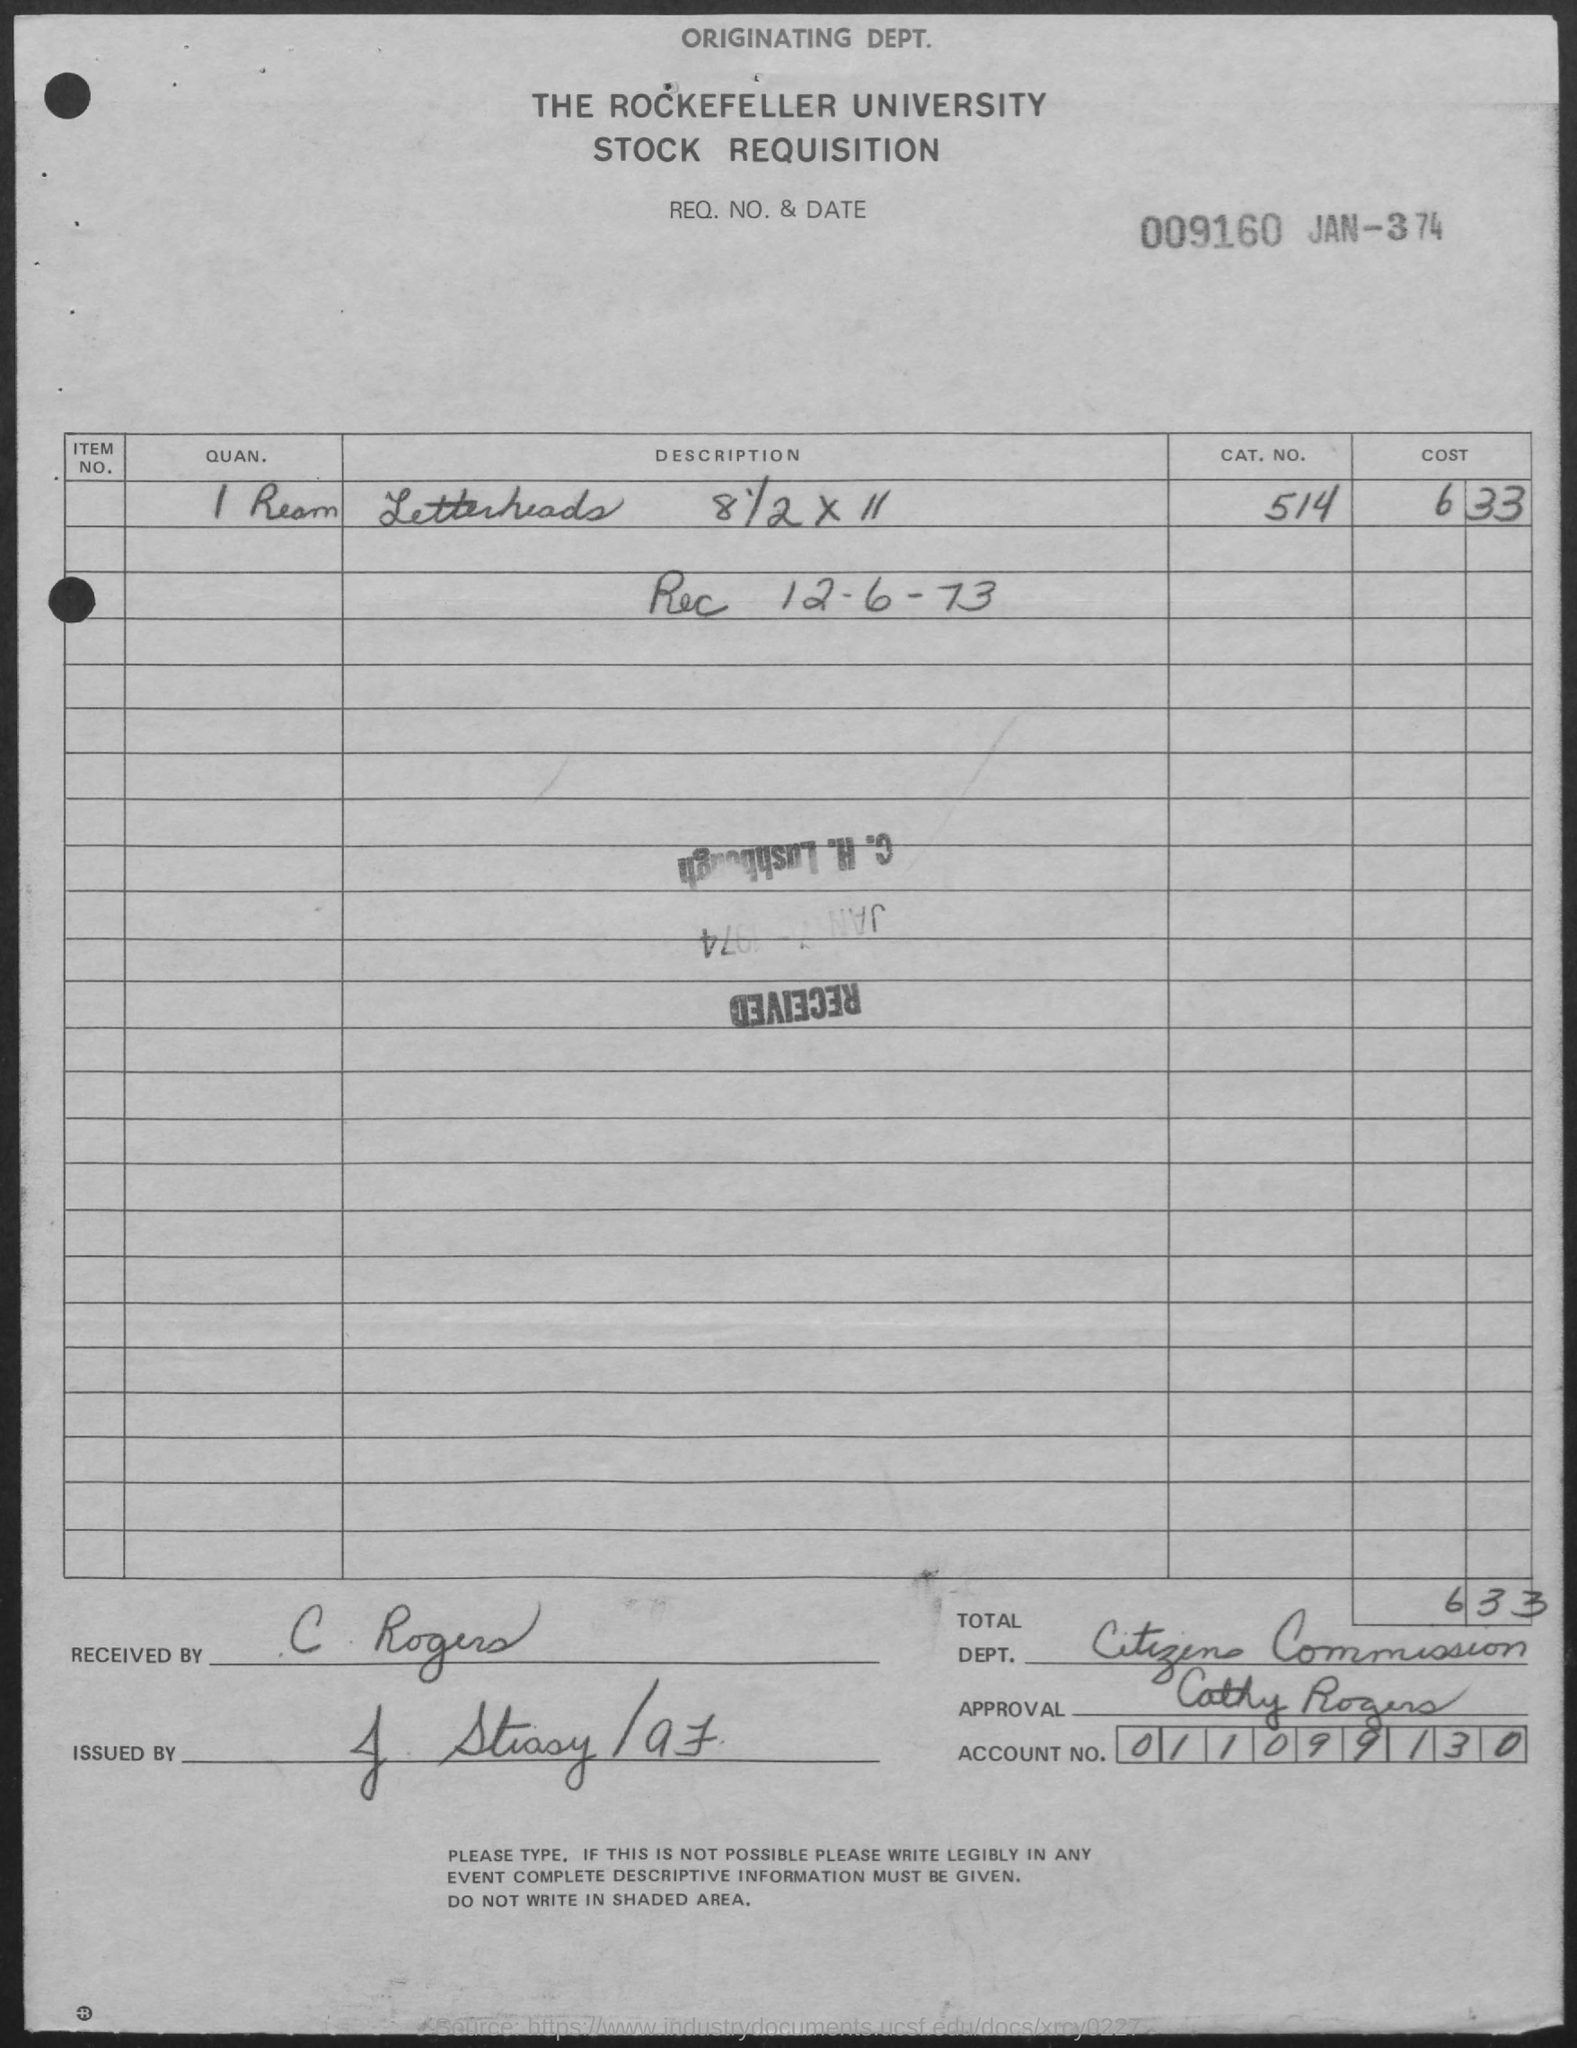What is the name of the university mentioned in the given letter ?
Keep it short and to the point. The Rockefeller University. What is the account no mentioned in the given page ?
Offer a very short reply. 011099130. What is the name of the department mentioned in the given page ?
Offer a terse response. Citizens Commission. What is the cat.no. mentioned in the given page ?
Provide a succinct answer. 514. What is the cost of letterheads as mentioned in the given page ?
Make the answer very short. 633. What is the quantity of letterheads mentioned in the given page ?
Your answer should be very brief. 1 Ream. By whom this letter was received ?
Provide a succinct answer. C. Rogers. 